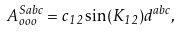<formula> <loc_0><loc_0><loc_500><loc_500>A _ { o o o } ^ { S a b c } = c _ { 1 2 } \sin ( K _ { 1 2 } ) d ^ { a b c } ,</formula> 